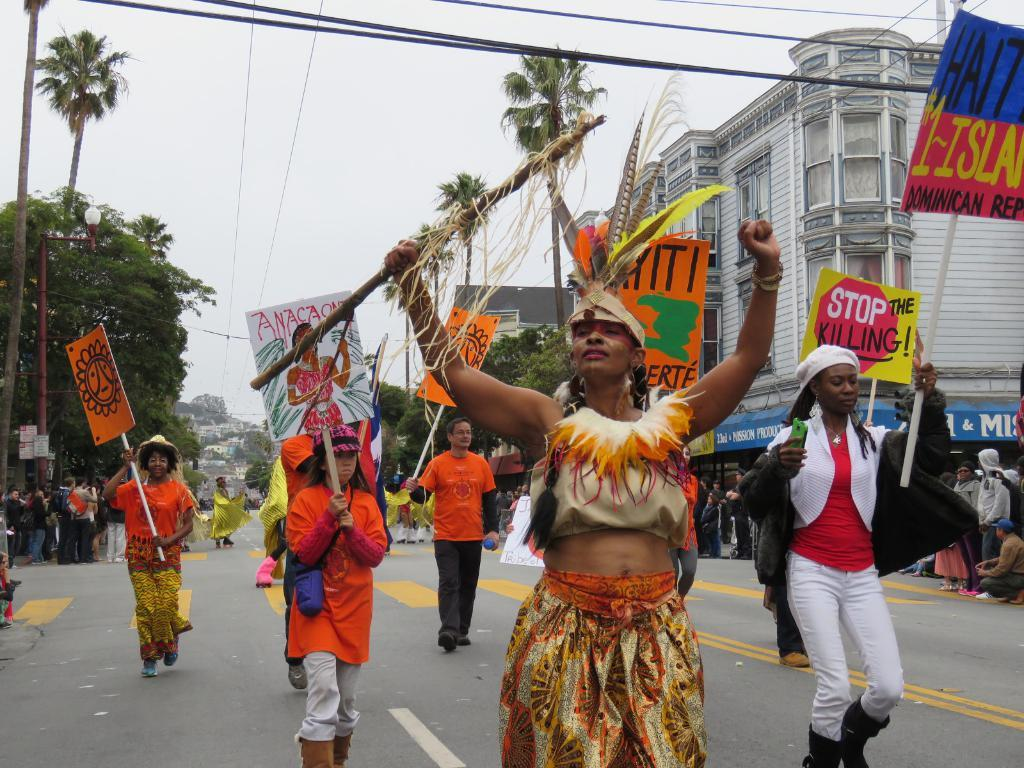What can be seen in the foreground of the picture? There are people on the road in the foreground of the picture. What is visible in the background of the picture? There are trees and buildings in the background of the picture. Can you describe the people in the center of the picture? Yes, there are people in the center of the picture. What is the condition of the sky in the picture? The sky is cloudy in the picture. What type of seed can be seen growing on the buildings in the image? There are no seeds visible on the buildings in the image. Can you hear the bell ringing in the image? There is no bell present in the image, so it cannot be heard. 